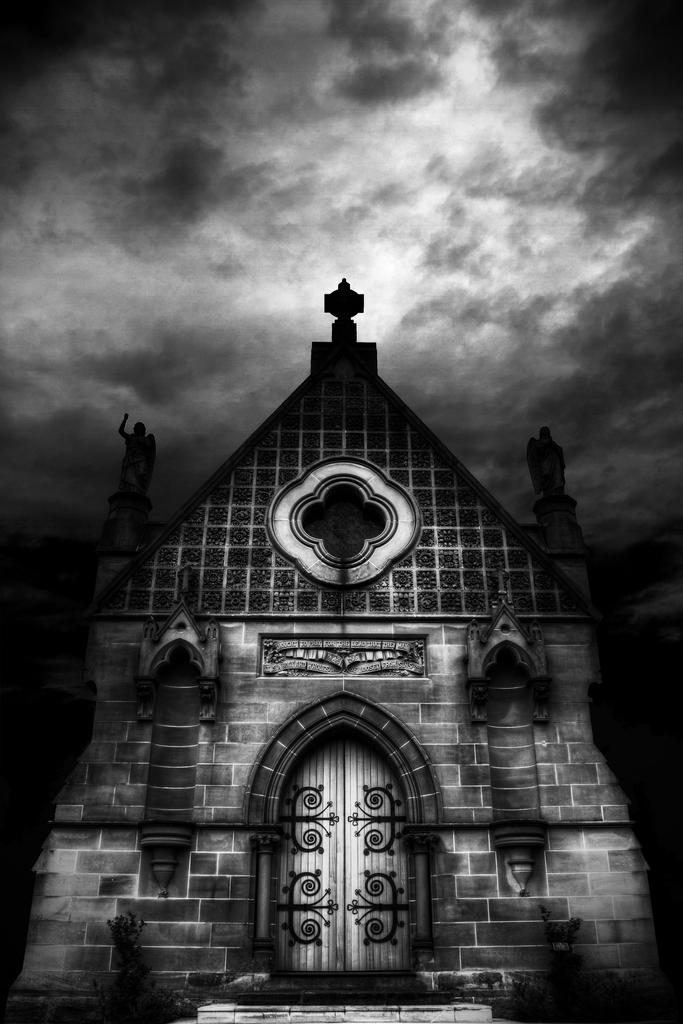What is the main structure visible in the picture? There is a building in the picture. What can be seen in the sky in the image? There are clouds in the sky. What type of stone is used to build the bushes in the image? There are no bushes present in the image, and therefore no stone can be associated with them. 